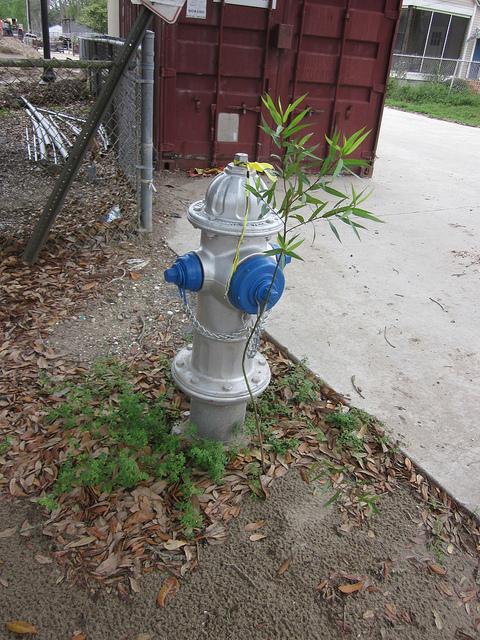How tall is the fire hydrant?
Keep it brief. 2 feet. What color is the fire hydrant?
Concise answer only. Silver and blue. Is there a plant next to the fire hydrant?
Keep it brief. Yes. 